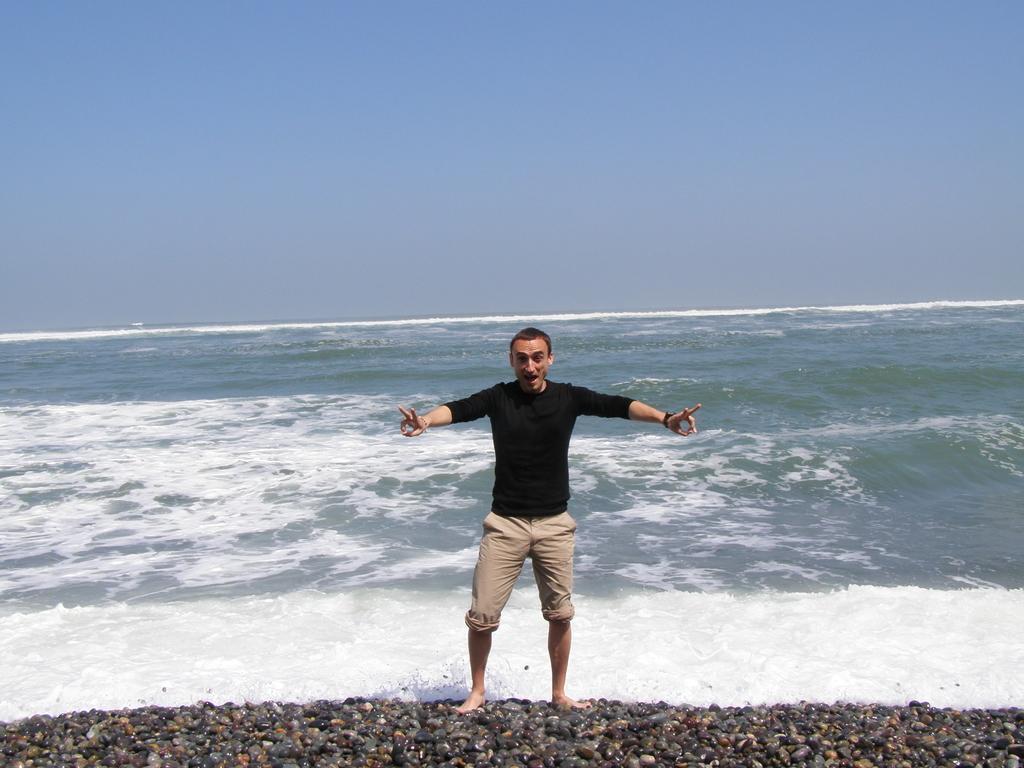Describe this image in one or two sentences. In this image we can see a person standing on stones. In the background of the image there is ocean and sky. 